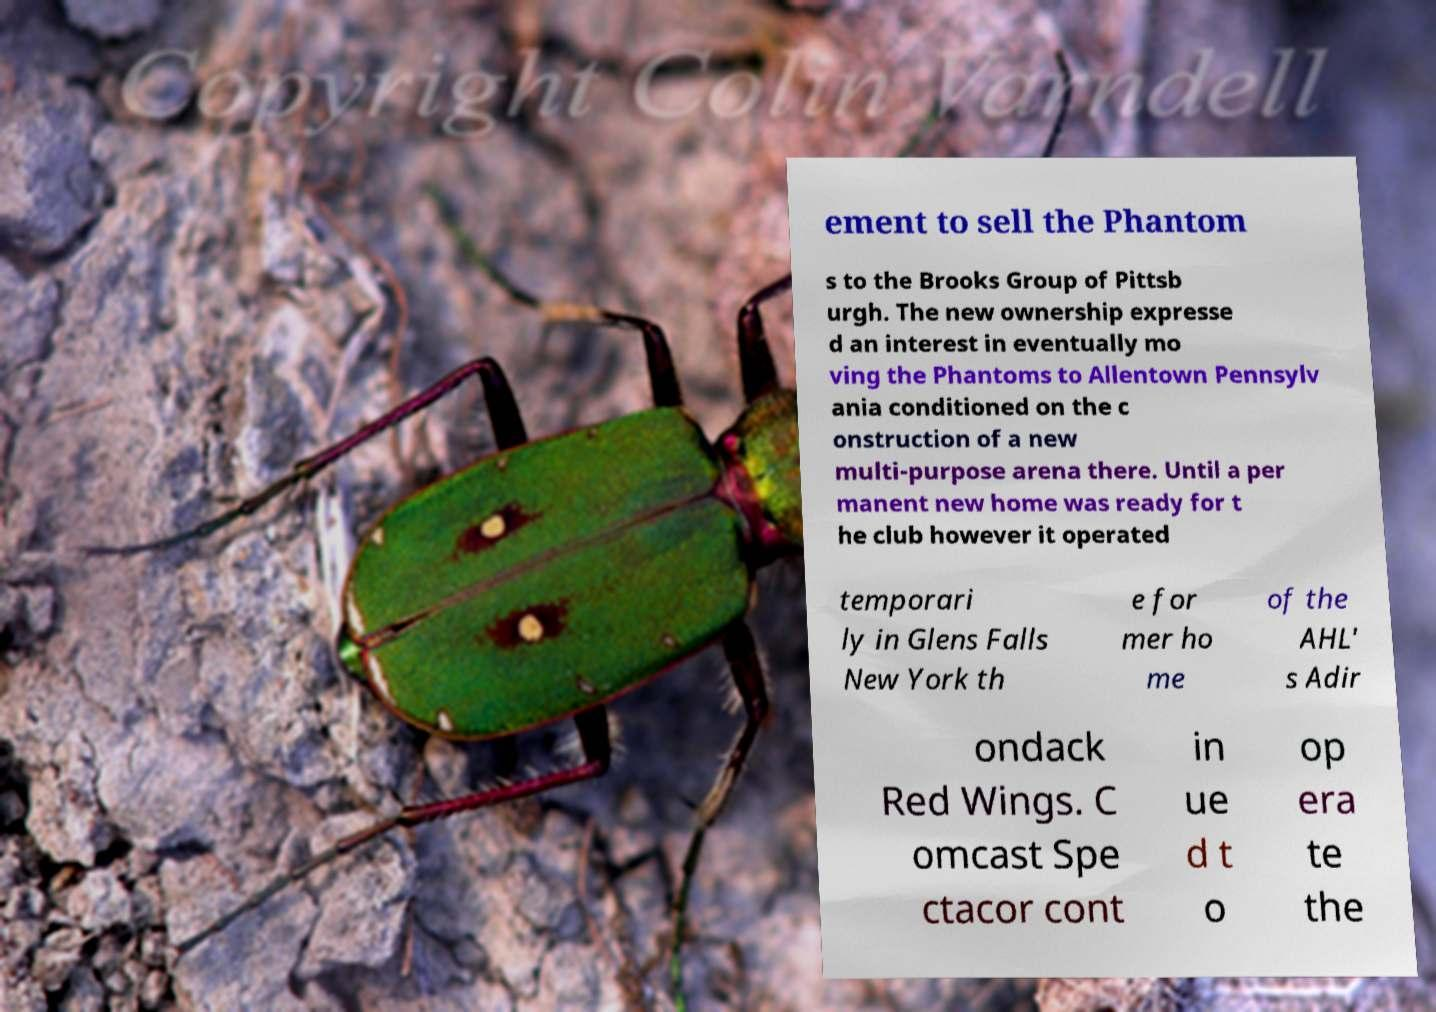Please read and relay the text visible in this image. What does it say? ement to sell the Phantom s to the Brooks Group of Pittsb urgh. The new ownership expresse d an interest in eventually mo ving the Phantoms to Allentown Pennsylv ania conditioned on the c onstruction of a new multi-purpose arena there. Until a per manent new home was ready for t he club however it operated temporari ly in Glens Falls New York th e for mer ho me of the AHL' s Adir ondack Red Wings. C omcast Spe ctacor cont in ue d t o op era te the 